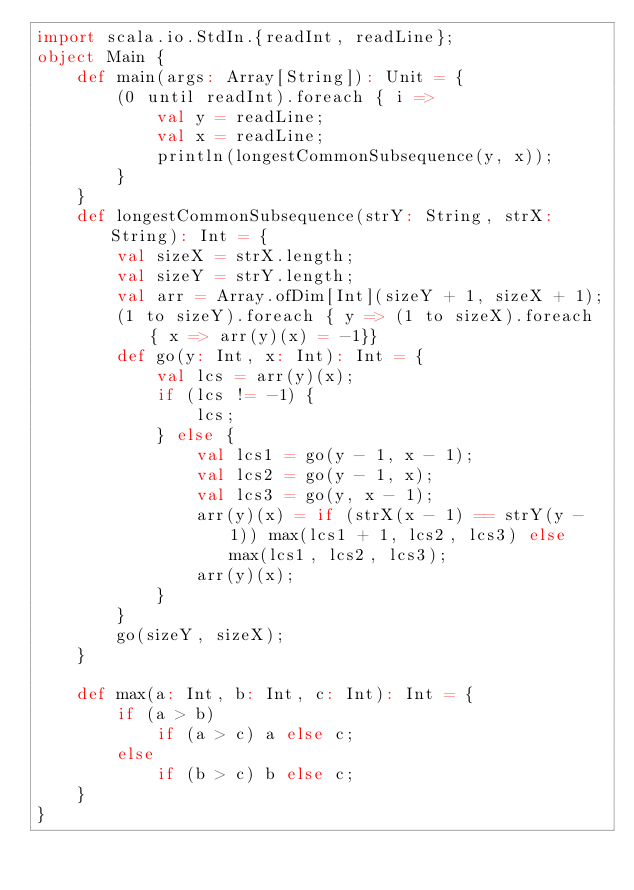<code> <loc_0><loc_0><loc_500><loc_500><_Scala_>import scala.io.StdIn.{readInt, readLine};
object Main {
    def main(args: Array[String]): Unit = {
        (0 until readInt).foreach { i =>
            val y = readLine;
            val x = readLine;
            println(longestCommonSubsequence(y, x));
        }
    }
    def longestCommonSubsequence(strY: String, strX: String): Int = {
        val sizeX = strX.length;
        val sizeY = strY.length;
        val arr = Array.ofDim[Int](sizeY + 1, sizeX + 1);
        (1 to sizeY).foreach { y => (1 to sizeX).foreach { x => arr(y)(x) = -1}}
        def go(y: Int, x: Int): Int = {
            val lcs = arr(y)(x);
            if (lcs != -1) {
                lcs;
            } else {
                val lcs1 = go(y - 1, x - 1);
                val lcs2 = go(y - 1, x);
                val lcs3 = go(y, x - 1);
                arr(y)(x) = if (strX(x - 1) == strY(y - 1)) max(lcs1 + 1, lcs2, lcs3) else  max(lcs1, lcs2, lcs3);
                arr(y)(x);
            }
        }
        go(sizeY, sizeX);
    }

    def max(a: Int, b: Int, c: Int): Int = {
        if (a > b)
            if (a > c) a else c;
        else
            if (b > c) b else c;
    }
}
</code> 